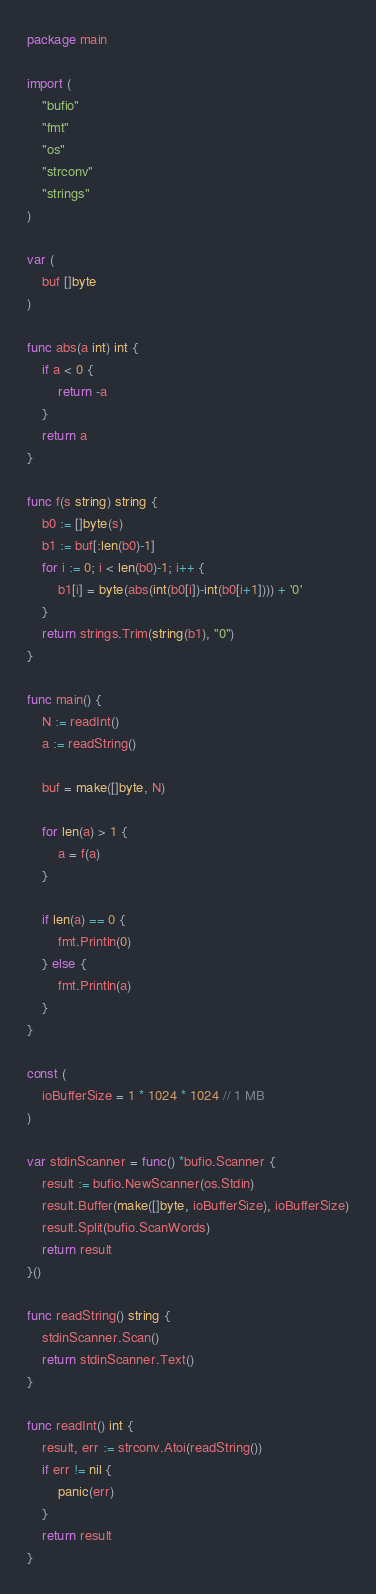<code> <loc_0><loc_0><loc_500><loc_500><_Go_>package main

import (
	"bufio"
	"fmt"
	"os"
	"strconv"
	"strings"
)

var (
	buf []byte
)

func abs(a int) int {
	if a < 0 {
		return -a
	}
	return a
}

func f(s string) string {
	b0 := []byte(s)
	b1 := buf[:len(b0)-1]
	for i := 0; i < len(b0)-1; i++ {
		b1[i] = byte(abs(int(b0[i])-int(b0[i+1]))) + '0'
	}
	return strings.Trim(string(b1), "0")
}

func main() {
	N := readInt()
	a := readString()

	buf = make([]byte, N)

	for len(a) > 1 {
		a = f(a)
	}

	if len(a) == 0 {
		fmt.Println(0)
	} else {
		fmt.Println(a)
	}
}

const (
	ioBufferSize = 1 * 1024 * 1024 // 1 MB
)

var stdinScanner = func() *bufio.Scanner {
	result := bufio.NewScanner(os.Stdin)
	result.Buffer(make([]byte, ioBufferSize), ioBufferSize)
	result.Split(bufio.ScanWords)
	return result
}()

func readString() string {
	stdinScanner.Scan()
	return stdinScanner.Text()
}

func readInt() int {
	result, err := strconv.Atoi(readString())
	if err != nil {
		panic(err)
	}
	return result
}
</code> 